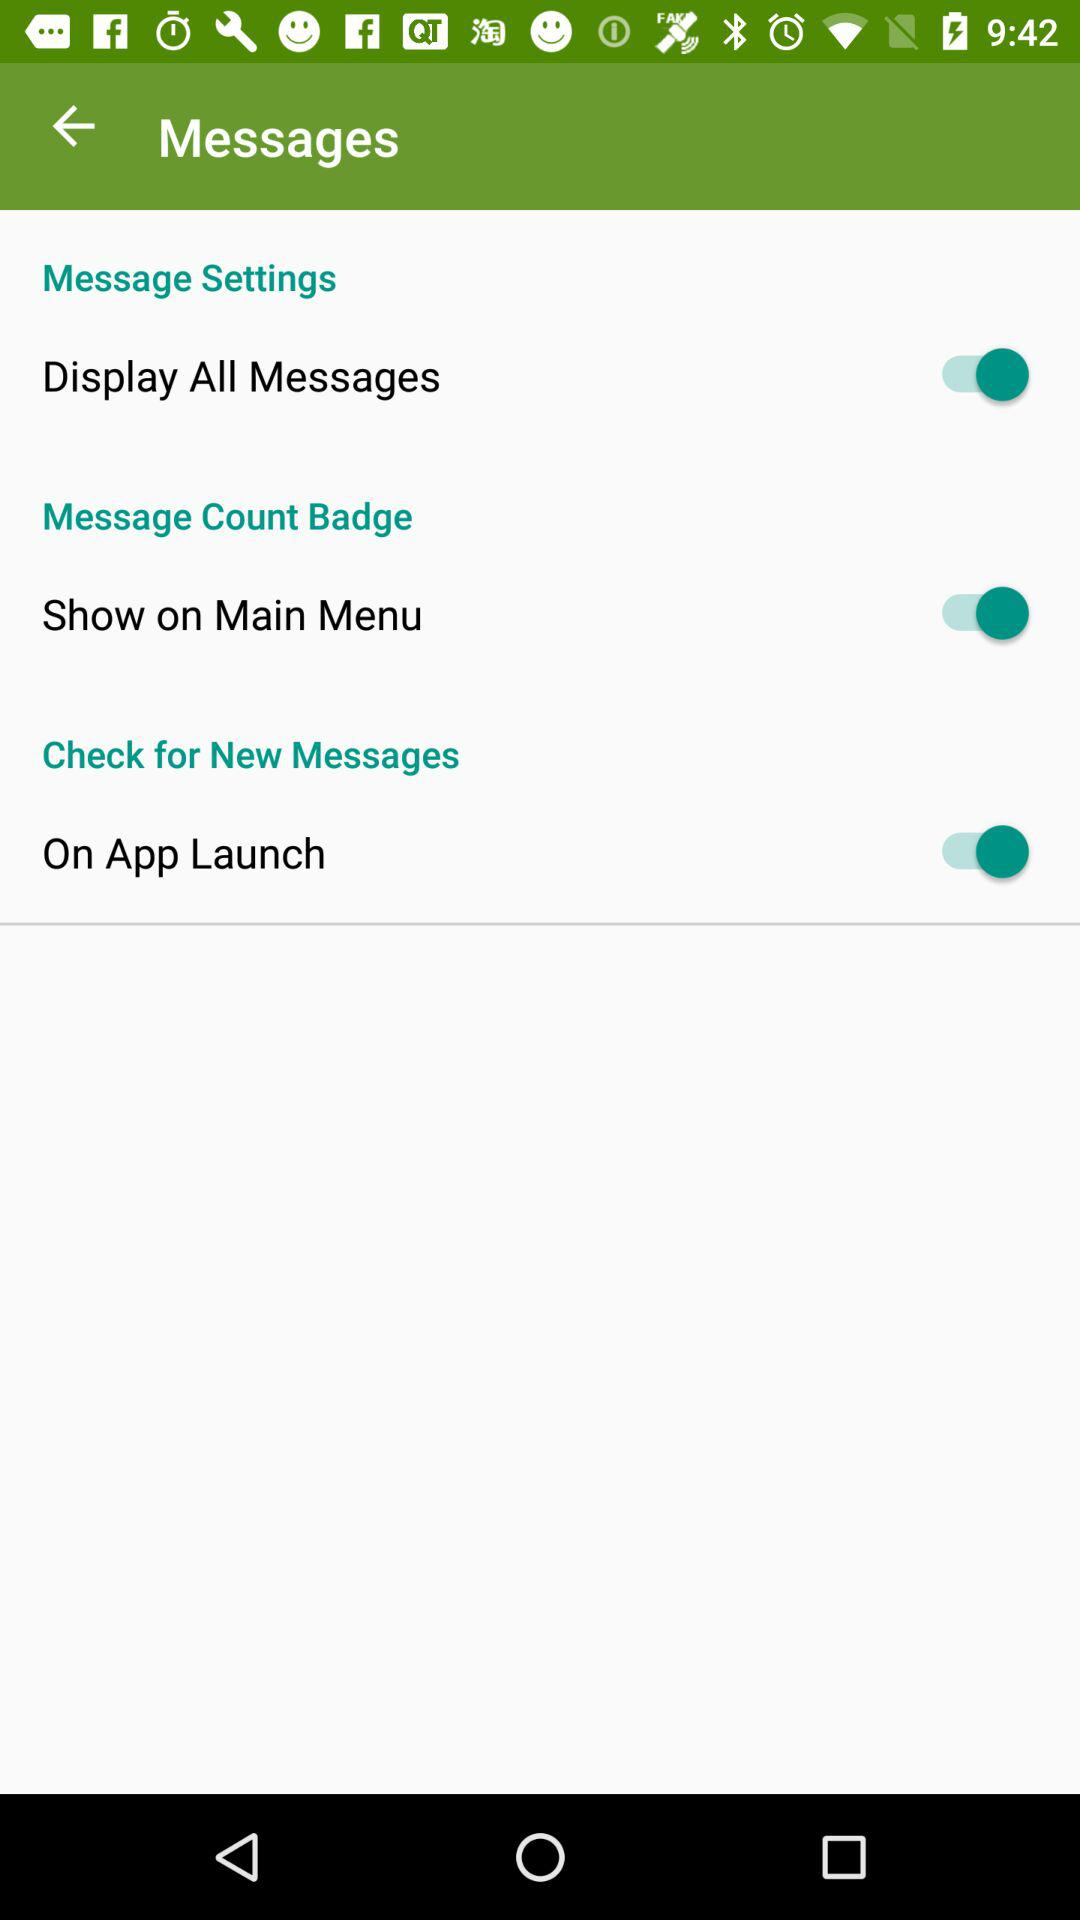How many message settings can be toggled?
Answer the question using a single word or phrase. 3 